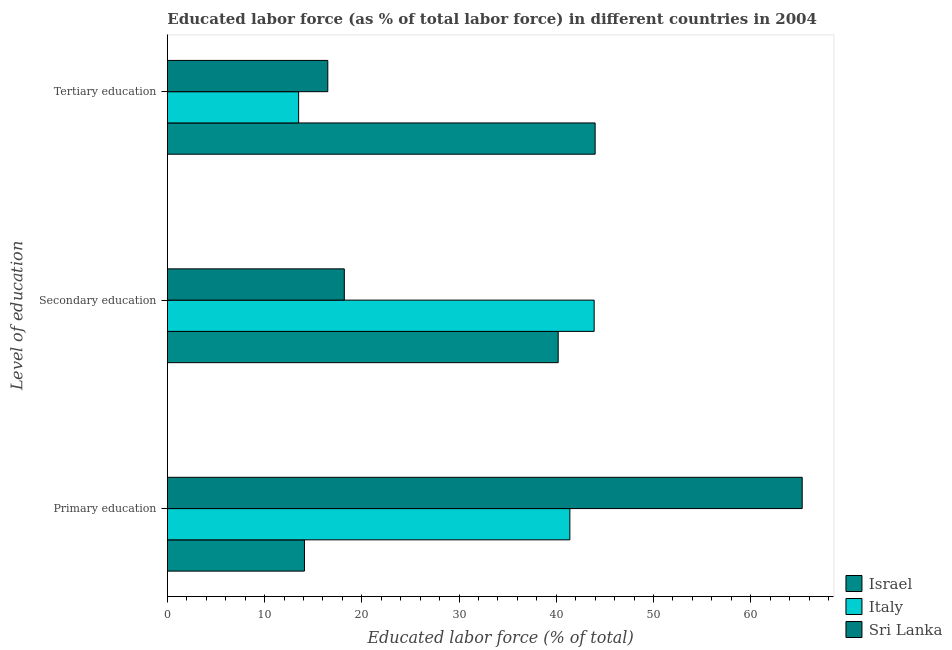How many different coloured bars are there?
Ensure brevity in your answer.  3. How many groups of bars are there?
Offer a terse response. 3. Are the number of bars per tick equal to the number of legend labels?
Your answer should be compact. Yes. What is the label of the 1st group of bars from the top?
Offer a very short reply. Tertiary education. What is the percentage of labor force who received secondary education in Italy?
Your answer should be compact. 43.9. Across all countries, what is the minimum percentage of labor force who received secondary education?
Your answer should be compact. 18.2. In which country was the percentage of labor force who received primary education minimum?
Your answer should be compact. Israel. What is the total percentage of labor force who received primary education in the graph?
Ensure brevity in your answer.  120.8. What is the difference between the percentage of labor force who received tertiary education in Italy and that in Sri Lanka?
Your response must be concise. -3. What is the difference between the percentage of labor force who received secondary education in Israel and the percentage of labor force who received primary education in Italy?
Your answer should be very brief. -1.2. What is the average percentage of labor force who received secondary education per country?
Keep it short and to the point. 34.1. What is the difference between the percentage of labor force who received primary education and percentage of labor force who received secondary education in Sri Lanka?
Offer a terse response. 47.1. In how many countries, is the percentage of labor force who received primary education greater than 22 %?
Ensure brevity in your answer.  2. What is the ratio of the percentage of labor force who received secondary education in Sri Lanka to that in Italy?
Give a very brief answer. 0.41. Is the percentage of labor force who received tertiary education in Israel less than that in Sri Lanka?
Your answer should be compact. No. What is the difference between the highest and the second highest percentage of labor force who received primary education?
Your answer should be compact. 23.9. What is the difference between the highest and the lowest percentage of labor force who received primary education?
Your answer should be very brief. 51.2. In how many countries, is the percentage of labor force who received tertiary education greater than the average percentage of labor force who received tertiary education taken over all countries?
Make the answer very short. 1. Is the sum of the percentage of labor force who received tertiary education in Sri Lanka and Italy greater than the maximum percentage of labor force who received primary education across all countries?
Make the answer very short. No. What does the 1st bar from the top in Primary education represents?
Your answer should be very brief. Sri Lanka. How many bars are there?
Keep it short and to the point. 9. Are all the bars in the graph horizontal?
Provide a succinct answer. Yes. How many countries are there in the graph?
Make the answer very short. 3. Are the values on the major ticks of X-axis written in scientific E-notation?
Offer a terse response. No. Does the graph contain grids?
Provide a short and direct response. No. Where does the legend appear in the graph?
Ensure brevity in your answer.  Bottom right. How are the legend labels stacked?
Your answer should be compact. Vertical. What is the title of the graph?
Provide a succinct answer. Educated labor force (as % of total labor force) in different countries in 2004. What is the label or title of the X-axis?
Make the answer very short. Educated labor force (% of total). What is the label or title of the Y-axis?
Keep it short and to the point. Level of education. What is the Educated labor force (% of total) of Israel in Primary education?
Provide a succinct answer. 14.1. What is the Educated labor force (% of total) of Italy in Primary education?
Provide a succinct answer. 41.4. What is the Educated labor force (% of total) of Sri Lanka in Primary education?
Keep it short and to the point. 65.3. What is the Educated labor force (% of total) in Israel in Secondary education?
Keep it short and to the point. 40.2. What is the Educated labor force (% of total) of Italy in Secondary education?
Your response must be concise. 43.9. What is the Educated labor force (% of total) of Sri Lanka in Secondary education?
Give a very brief answer. 18.2. What is the Educated labor force (% of total) of Italy in Tertiary education?
Provide a short and direct response. 13.5. Across all Level of education, what is the maximum Educated labor force (% of total) in Israel?
Give a very brief answer. 44. Across all Level of education, what is the maximum Educated labor force (% of total) in Italy?
Your answer should be compact. 43.9. Across all Level of education, what is the maximum Educated labor force (% of total) of Sri Lanka?
Provide a succinct answer. 65.3. Across all Level of education, what is the minimum Educated labor force (% of total) of Israel?
Ensure brevity in your answer.  14.1. Across all Level of education, what is the minimum Educated labor force (% of total) of Italy?
Make the answer very short. 13.5. Across all Level of education, what is the minimum Educated labor force (% of total) of Sri Lanka?
Offer a very short reply. 16.5. What is the total Educated labor force (% of total) in Israel in the graph?
Offer a terse response. 98.3. What is the total Educated labor force (% of total) in Italy in the graph?
Offer a terse response. 98.8. What is the total Educated labor force (% of total) in Sri Lanka in the graph?
Ensure brevity in your answer.  100. What is the difference between the Educated labor force (% of total) of Israel in Primary education and that in Secondary education?
Your response must be concise. -26.1. What is the difference between the Educated labor force (% of total) in Italy in Primary education and that in Secondary education?
Provide a short and direct response. -2.5. What is the difference between the Educated labor force (% of total) of Sri Lanka in Primary education and that in Secondary education?
Offer a very short reply. 47.1. What is the difference between the Educated labor force (% of total) in Israel in Primary education and that in Tertiary education?
Provide a short and direct response. -29.9. What is the difference between the Educated labor force (% of total) in Italy in Primary education and that in Tertiary education?
Your answer should be compact. 27.9. What is the difference between the Educated labor force (% of total) in Sri Lanka in Primary education and that in Tertiary education?
Provide a succinct answer. 48.8. What is the difference between the Educated labor force (% of total) in Italy in Secondary education and that in Tertiary education?
Offer a very short reply. 30.4. What is the difference between the Educated labor force (% of total) of Sri Lanka in Secondary education and that in Tertiary education?
Make the answer very short. 1.7. What is the difference between the Educated labor force (% of total) of Israel in Primary education and the Educated labor force (% of total) of Italy in Secondary education?
Your answer should be compact. -29.8. What is the difference between the Educated labor force (% of total) of Israel in Primary education and the Educated labor force (% of total) of Sri Lanka in Secondary education?
Your answer should be very brief. -4.1. What is the difference between the Educated labor force (% of total) of Italy in Primary education and the Educated labor force (% of total) of Sri Lanka in Secondary education?
Keep it short and to the point. 23.2. What is the difference between the Educated labor force (% of total) of Italy in Primary education and the Educated labor force (% of total) of Sri Lanka in Tertiary education?
Provide a short and direct response. 24.9. What is the difference between the Educated labor force (% of total) in Israel in Secondary education and the Educated labor force (% of total) in Italy in Tertiary education?
Your answer should be very brief. 26.7. What is the difference between the Educated labor force (% of total) in Israel in Secondary education and the Educated labor force (% of total) in Sri Lanka in Tertiary education?
Ensure brevity in your answer.  23.7. What is the difference between the Educated labor force (% of total) in Italy in Secondary education and the Educated labor force (% of total) in Sri Lanka in Tertiary education?
Your answer should be compact. 27.4. What is the average Educated labor force (% of total) of Israel per Level of education?
Offer a very short reply. 32.77. What is the average Educated labor force (% of total) of Italy per Level of education?
Give a very brief answer. 32.93. What is the average Educated labor force (% of total) of Sri Lanka per Level of education?
Make the answer very short. 33.33. What is the difference between the Educated labor force (% of total) in Israel and Educated labor force (% of total) in Italy in Primary education?
Your answer should be compact. -27.3. What is the difference between the Educated labor force (% of total) in Israel and Educated labor force (% of total) in Sri Lanka in Primary education?
Give a very brief answer. -51.2. What is the difference between the Educated labor force (% of total) of Italy and Educated labor force (% of total) of Sri Lanka in Primary education?
Your answer should be compact. -23.9. What is the difference between the Educated labor force (% of total) in Israel and Educated labor force (% of total) in Italy in Secondary education?
Provide a short and direct response. -3.7. What is the difference between the Educated labor force (% of total) of Israel and Educated labor force (% of total) of Sri Lanka in Secondary education?
Ensure brevity in your answer.  22. What is the difference between the Educated labor force (% of total) in Italy and Educated labor force (% of total) in Sri Lanka in Secondary education?
Keep it short and to the point. 25.7. What is the difference between the Educated labor force (% of total) in Israel and Educated labor force (% of total) in Italy in Tertiary education?
Offer a very short reply. 30.5. What is the difference between the Educated labor force (% of total) of Israel and Educated labor force (% of total) of Sri Lanka in Tertiary education?
Make the answer very short. 27.5. What is the difference between the Educated labor force (% of total) in Italy and Educated labor force (% of total) in Sri Lanka in Tertiary education?
Provide a succinct answer. -3. What is the ratio of the Educated labor force (% of total) in Israel in Primary education to that in Secondary education?
Your answer should be very brief. 0.35. What is the ratio of the Educated labor force (% of total) in Italy in Primary education to that in Secondary education?
Make the answer very short. 0.94. What is the ratio of the Educated labor force (% of total) of Sri Lanka in Primary education to that in Secondary education?
Your response must be concise. 3.59. What is the ratio of the Educated labor force (% of total) of Israel in Primary education to that in Tertiary education?
Keep it short and to the point. 0.32. What is the ratio of the Educated labor force (% of total) of Italy in Primary education to that in Tertiary education?
Provide a short and direct response. 3.07. What is the ratio of the Educated labor force (% of total) of Sri Lanka in Primary education to that in Tertiary education?
Provide a short and direct response. 3.96. What is the ratio of the Educated labor force (% of total) of Israel in Secondary education to that in Tertiary education?
Your answer should be compact. 0.91. What is the ratio of the Educated labor force (% of total) in Italy in Secondary education to that in Tertiary education?
Keep it short and to the point. 3.25. What is the ratio of the Educated labor force (% of total) of Sri Lanka in Secondary education to that in Tertiary education?
Your response must be concise. 1.1. What is the difference between the highest and the second highest Educated labor force (% of total) of Israel?
Provide a short and direct response. 3.8. What is the difference between the highest and the second highest Educated labor force (% of total) in Sri Lanka?
Your response must be concise. 47.1. What is the difference between the highest and the lowest Educated labor force (% of total) of Israel?
Your answer should be very brief. 29.9. What is the difference between the highest and the lowest Educated labor force (% of total) in Italy?
Ensure brevity in your answer.  30.4. What is the difference between the highest and the lowest Educated labor force (% of total) in Sri Lanka?
Give a very brief answer. 48.8. 